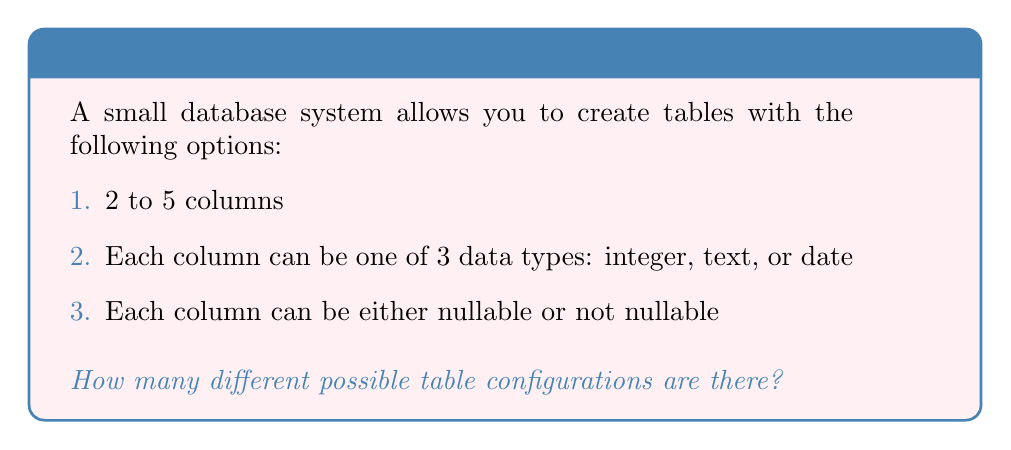Could you help me with this problem? Let's break this down step-by-step:

1. First, we need to consider the number of columns. We can have 2, 3, 4, or 5 columns. That's 4 possibilities.

2. For each column, we have 3 choices for data type (integer, text, or date).

3. Each column can also be either nullable or not nullable, which gives us 2 choices for each column.

4. For each possible number of columns, we need to calculate the number of configurations:

   - For 2 columns: $$(3 \times 2)^2 = 6^2 = 36$$
   - For 3 columns: $$(3 \times 2)^3 = 6^3 = 216$$
   - For 4 columns: $$(3 \times 2)^4 = 6^4 = 1,296$$
   - For 5 columns: $$(3 \times 2)^5 = 6^5 = 7,776$$

5. The total number of configurations is the sum of all these possibilities:

   $$36 + 216 + 1,296 + 7,776 = 9,324$$

Therefore, there are 9,324 different possible table configurations.
Answer: 9,324 